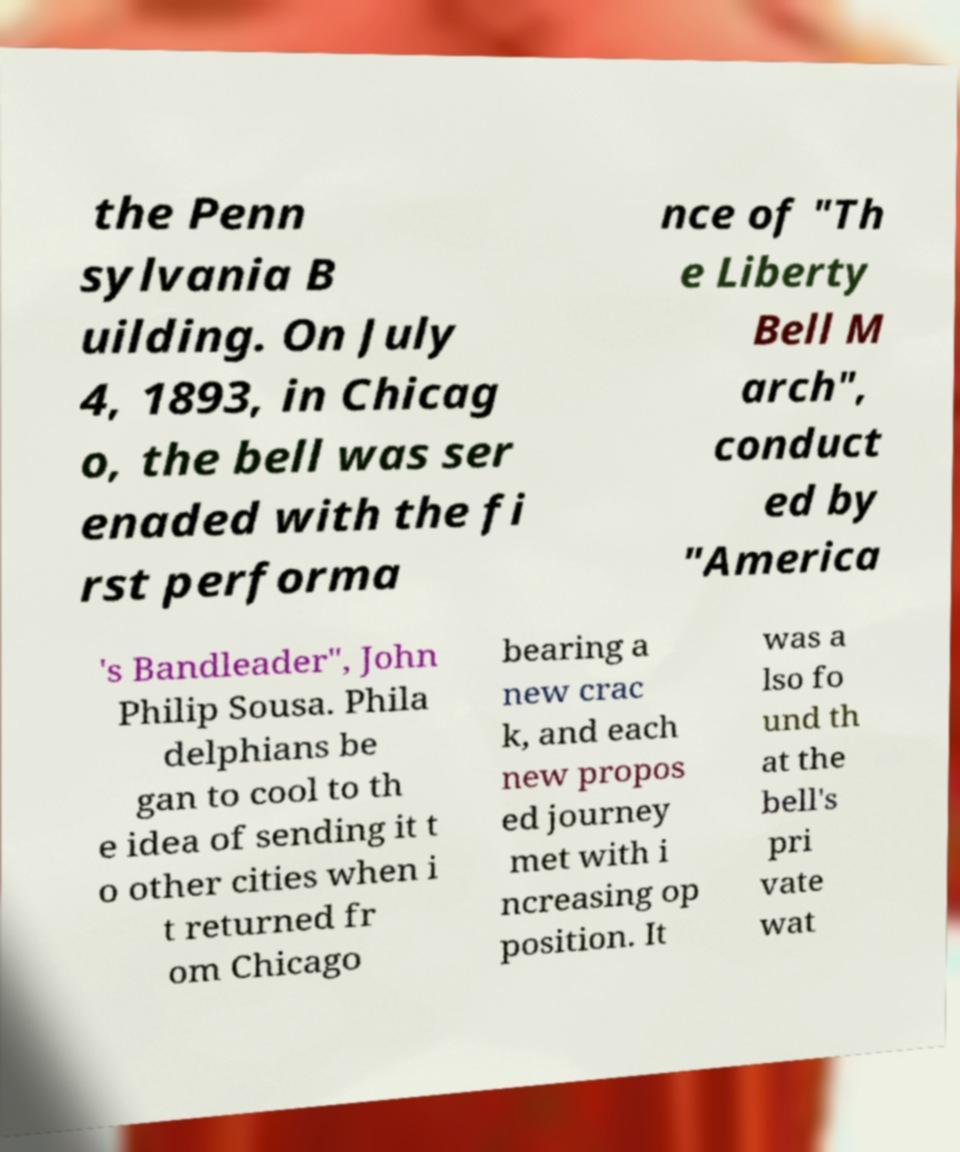Could you extract and type out the text from this image? the Penn sylvania B uilding. On July 4, 1893, in Chicag o, the bell was ser enaded with the fi rst performa nce of "Th e Liberty Bell M arch", conduct ed by "America 's Bandleader", John Philip Sousa. Phila delphians be gan to cool to th e idea of sending it t o other cities when i t returned fr om Chicago bearing a new crac k, and each new propos ed journey met with i ncreasing op position. It was a lso fo und th at the bell's pri vate wat 